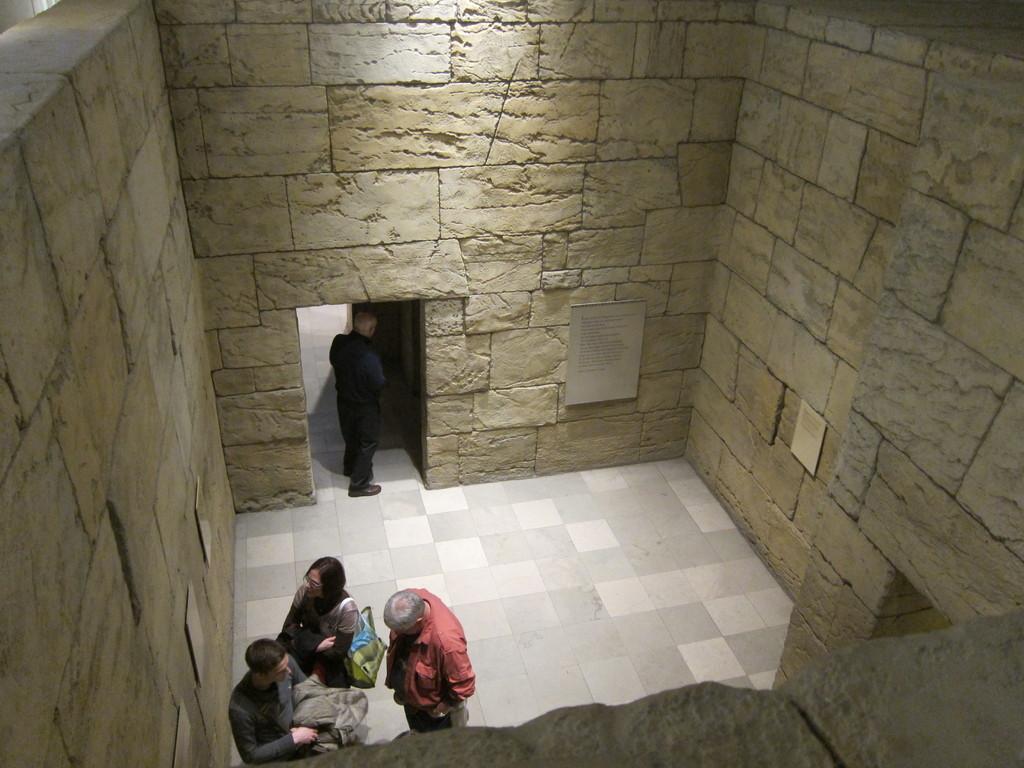Can you describe this image briefly? In this picture I can see four persons standing, there are boards on the walls. 